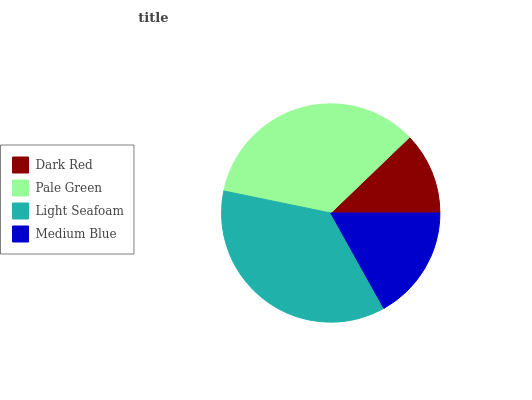Is Dark Red the minimum?
Answer yes or no. Yes. Is Light Seafoam the maximum?
Answer yes or no. Yes. Is Pale Green the minimum?
Answer yes or no. No. Is Pale Green the maximum?
Answer yes or no. No. Is Pale Green greater than Dark Red?
Answer yes or no. Yes. Is Dark Red less than Pale Green?
Answer yes or no. Yes. Is Dark Red greater than Pale Green?
Answer yes or no. No. Is Pale Green less than Dark Red?
Answer yes or no. No. Is Pale Green the high median?
Answer yes or no. Yes. Is Medium Blue the low median?
Answer yes or no. Yes. Is Dark Red the high median?
Answer yes or no. No. Is Light Seafoam the low median?
Answer yes or no. No. 